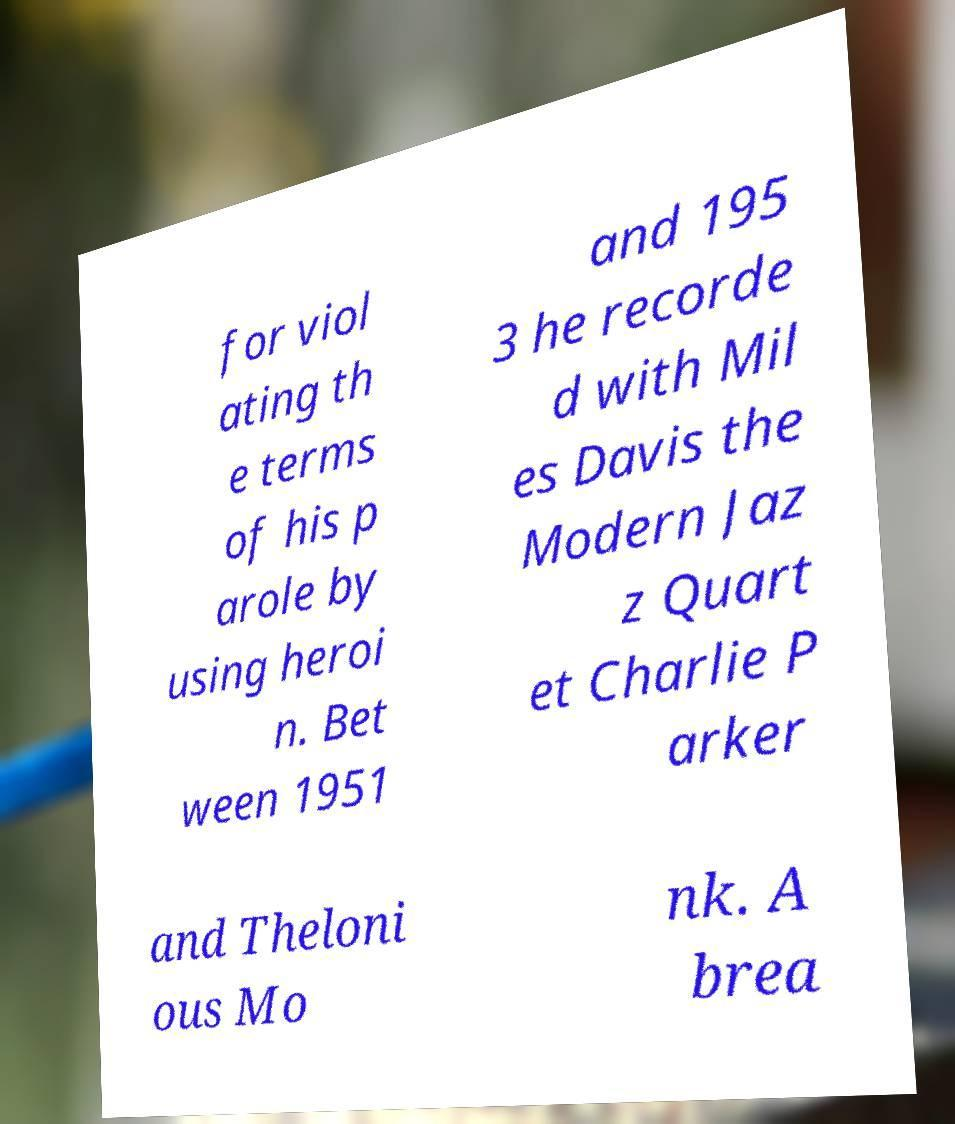For documentation purposes, I need the text within this image transcribed. Could you provide that? for viol ating th e terms of his p arole by using heroi n. Bet ween 1951 and 195 3 he recorde d with Mil es Davis the Modern Jaz z Quart et Charlie P arker and Theloni ous Mo nk. A brea 